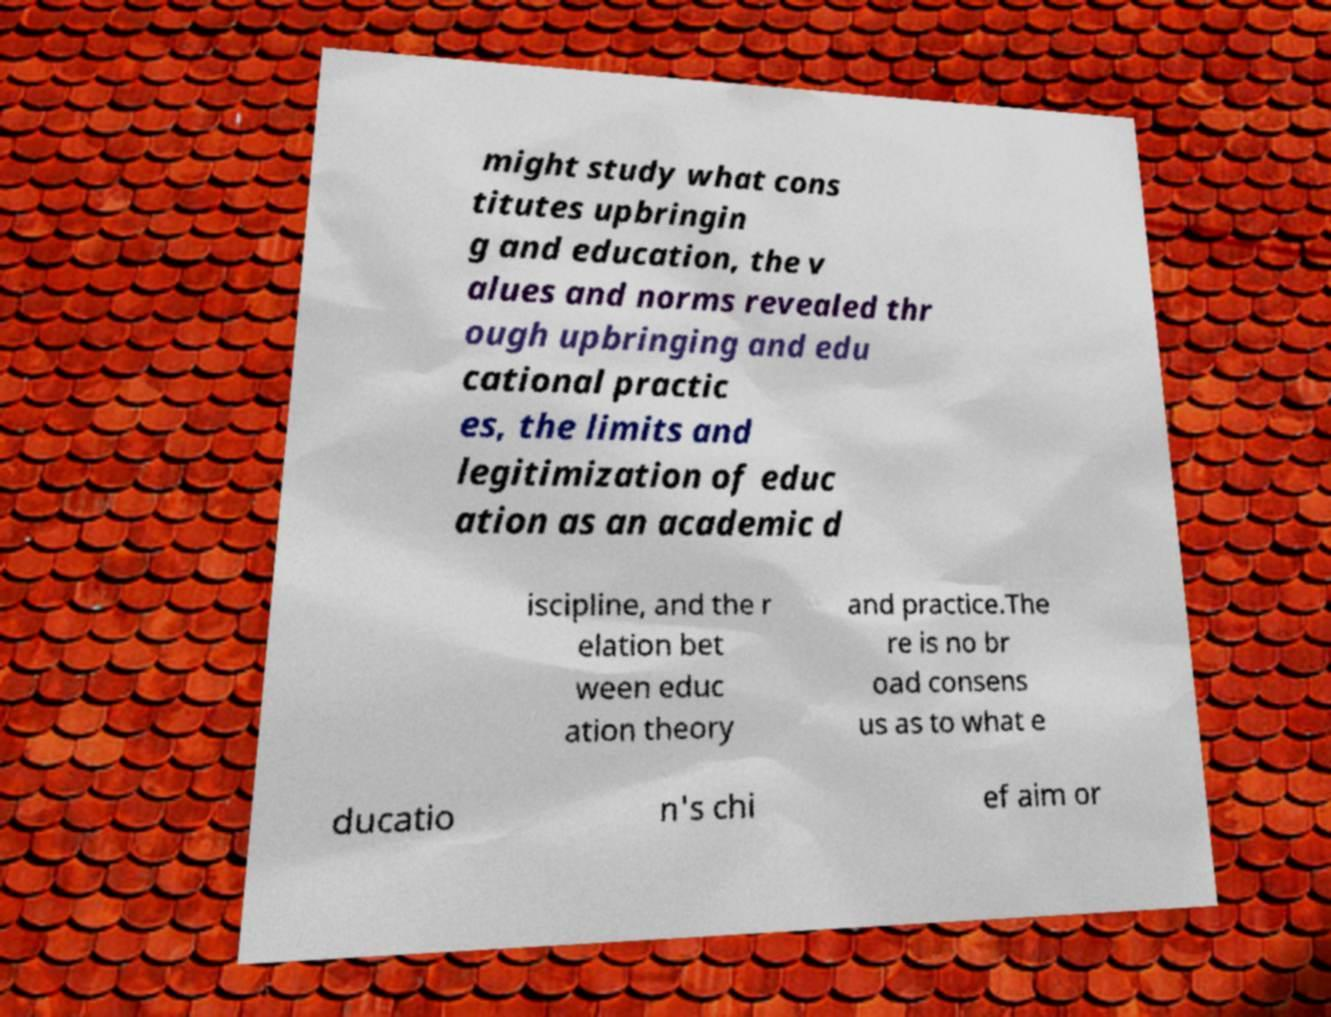Please identify and transcribe the text found in this image. might study what cons titutes upbringin g and education, the v alues and norms revealed thr ough upbringing and edu cational practic es, the limits and legitimization of educ ation as an academic d iscipline, and the r elation bet ween educ ation theory and practice.The re is no br oad consens us as to what e ducatio n's chi ef aim or 